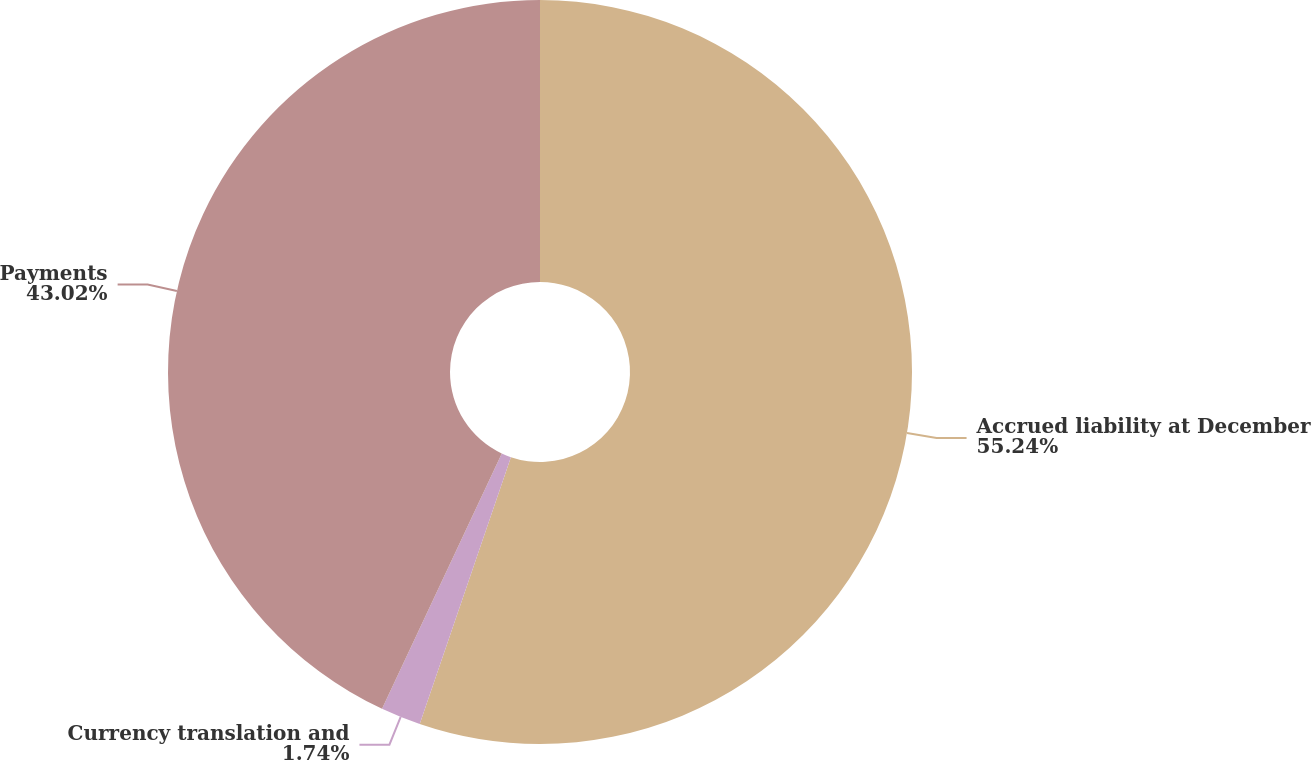Convert chart. <chart><loc_0><loc_0><loc_500><loc_500><pie_chart><fcel>Accrued liability at December<fcel>Currency translation and<fcel>Payments<nl><fcel>55.24%<fcel>1.74%<fcel>43.02%<nl></chart> 